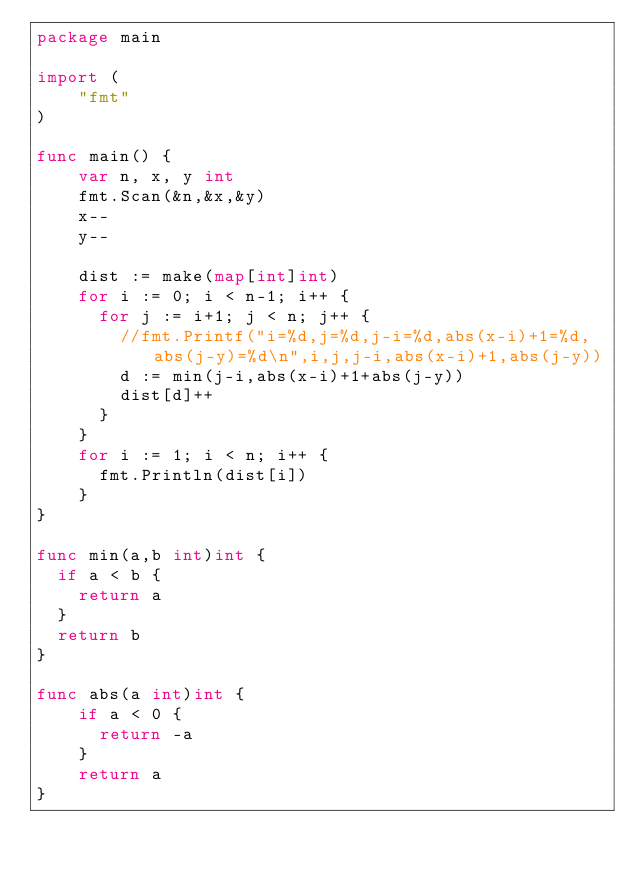<code> <loc_0><loc_0><loc_500><loc_500><_Go_>package main

import (
	"fmt"
)

func main() {
  	var n, x, y int
  	fmt.Scan(&n,&x,&y)
  	x--
    y--
  
  	dist := make(map[int]int)
    for i := 0; i < n-1; i++ {
      for j := i+1; j < n; j++ {
        //fmt.Printf("i=%d,j=%d,j-i=%d,abs(x-i)+1=%d,abs(j-y)=%d\n",i,j,j-i,abs(x-i)+1,abs(j-y))
        d := min(j-i,abs(x-i)+1+abs(j-y))
        dist[d]++
      }
    }
    for i := 1; i < n; i++ {
      fmt.Println(dist[i])
    }
}

func min(a,b int)int {
  if a < b {
  	return a
  }
  return b
}

func abs(a int)int {
    if a < 0 {
      return -a
    }
    return a
}</code> 